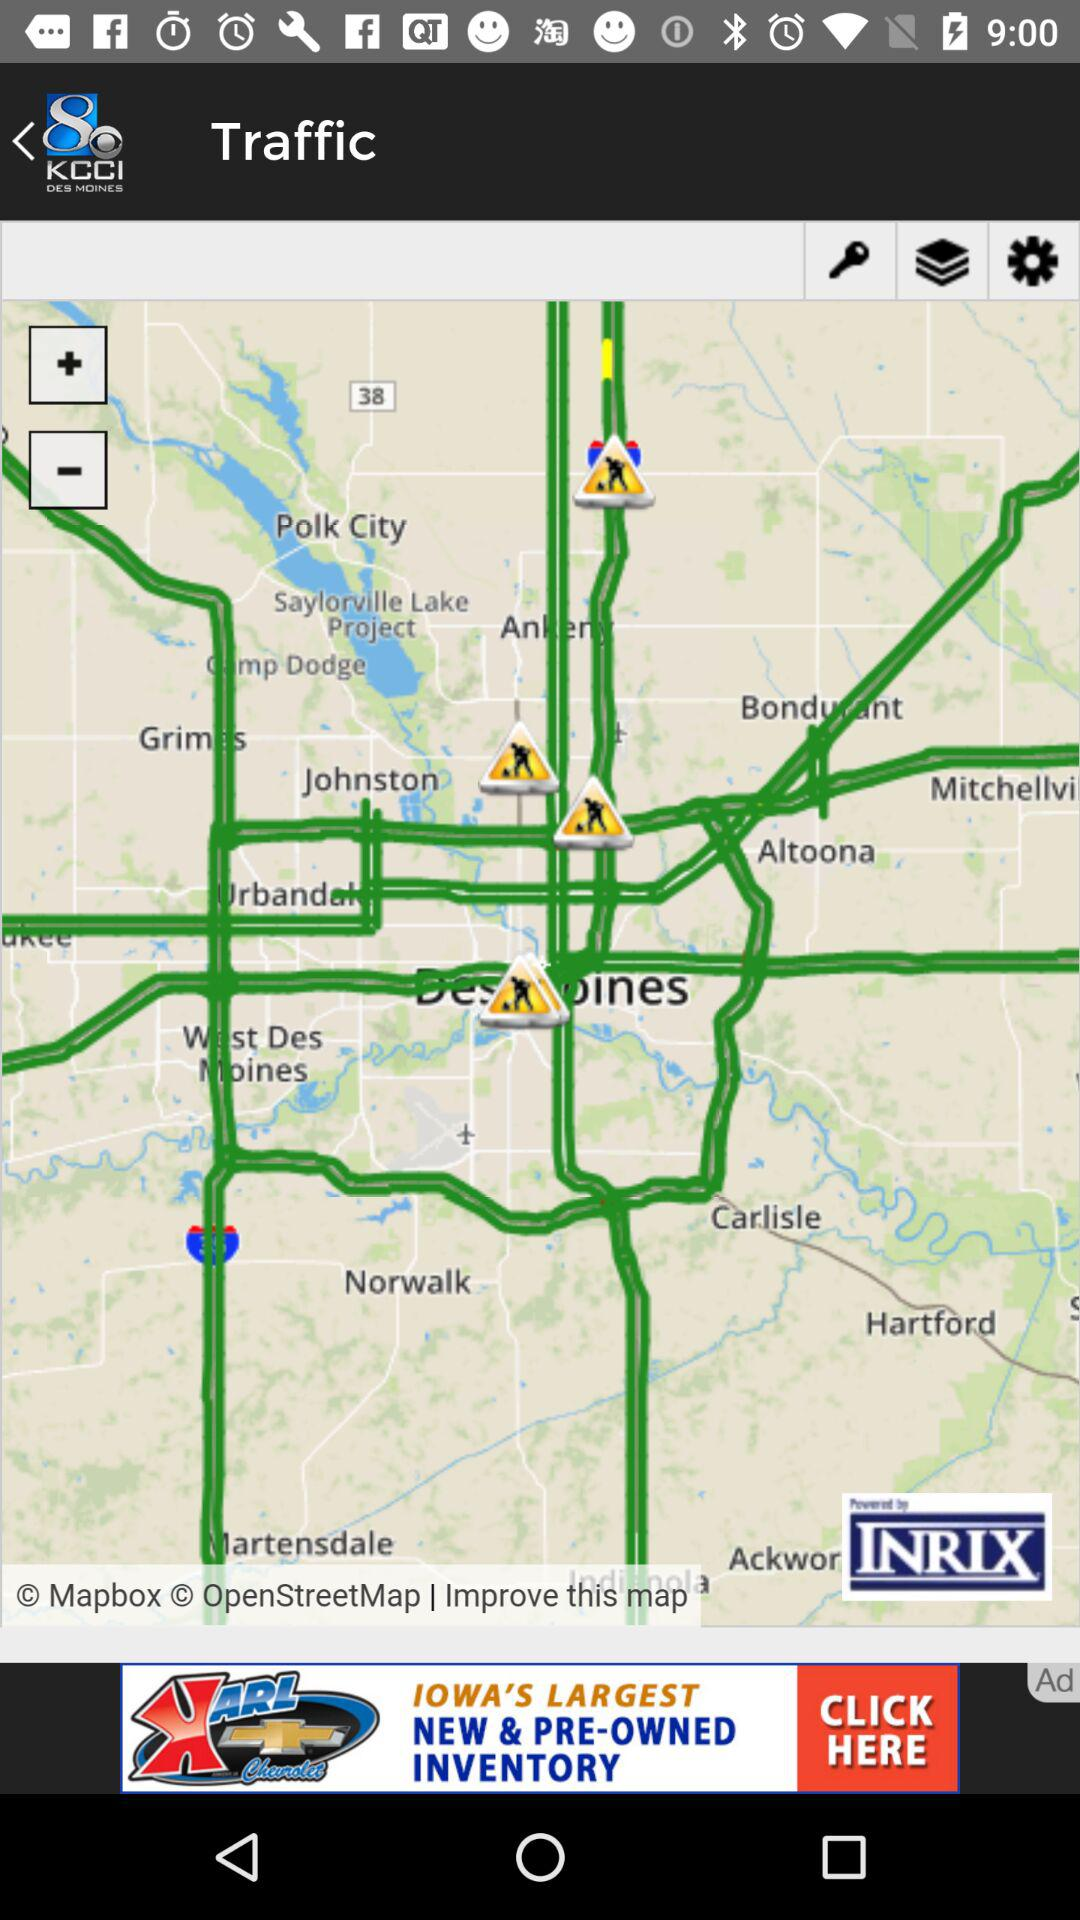What is the application name? The application name is "KCCI 8 News and Weather". 